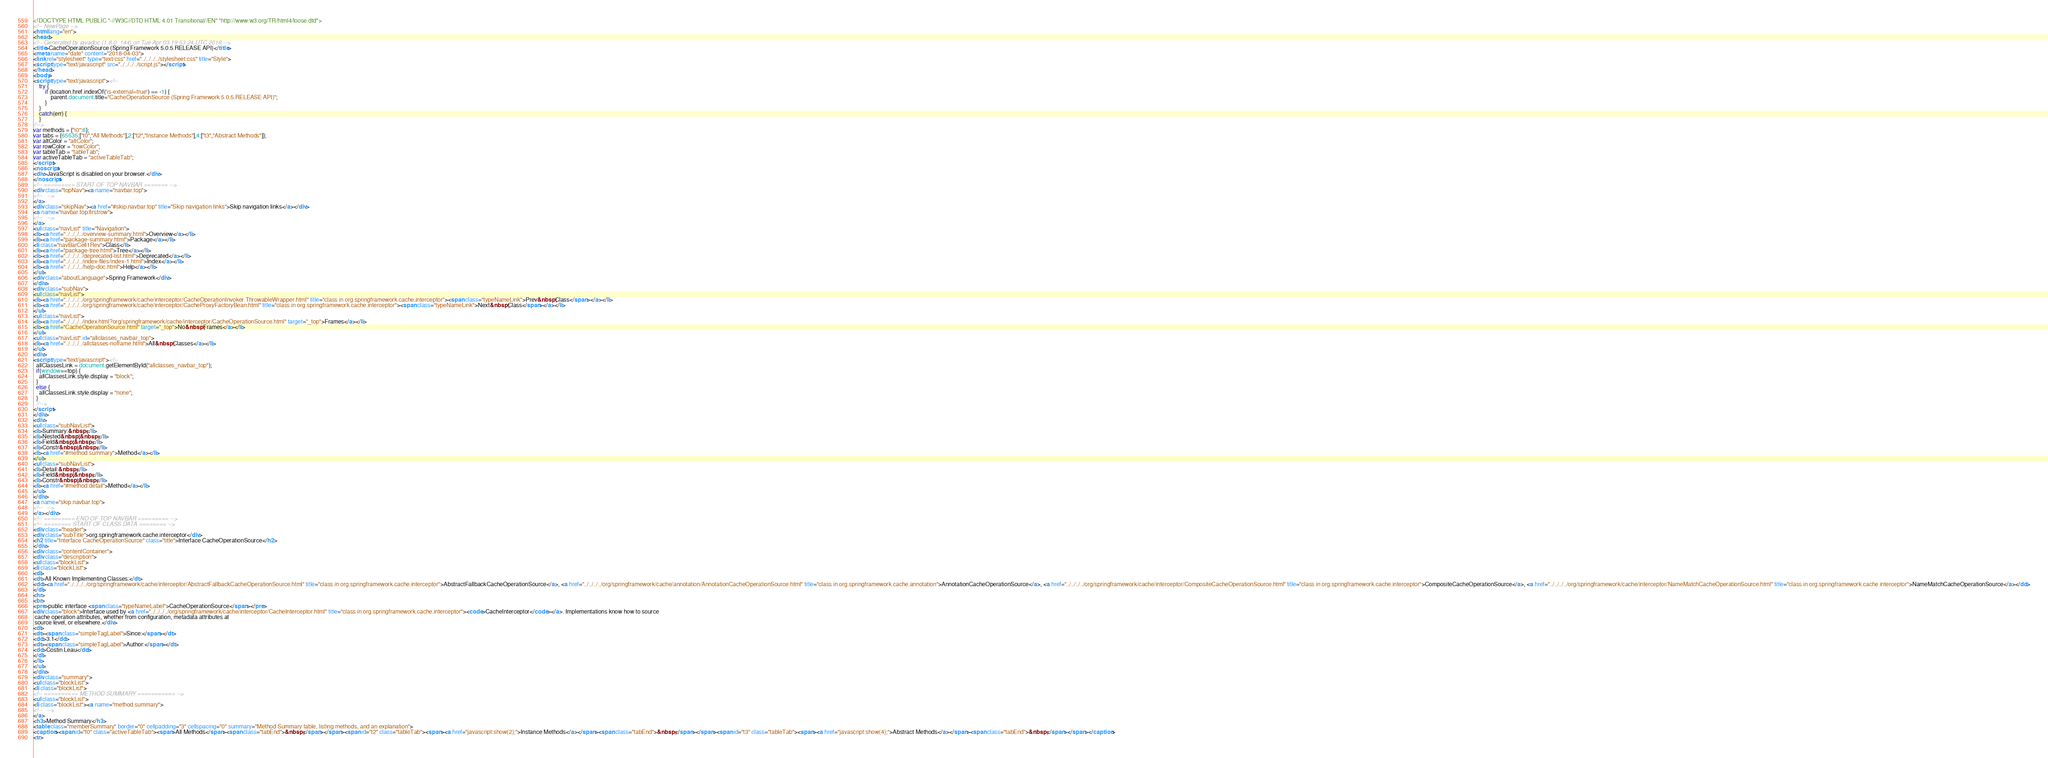<code> <loc_0><loc_0><loc_500><loc_500><_HTML_><!DOCTYPE HTML PUBLIC "-//W3C//DTD HTML 4.01 Transitional//EN" "http://www.w3.org/TR/html4/loose.dtd">
<!-- NewPage -->
<html lang="en">
<head>
<!-- Generated by javadoc (1.8.0_144) on Tue Apr 03 19:53:24 UTC 2018 -->
<title>CacheOperationSource (Spring Framework 5.0.5.RELEASE API)</title>
<meta name="date" content="2018-04-03">
<link rel="stylesheet" type="text/css" href="../../../../stylesheet.css" title="Style">
<script type="text/javascript" src="../../../../script.js"></script>
</head>
<body>
<script type="text/javascript"><!--
    try {
        if (location.href.indexOf('is-external=true') == -1) {
            parent.document.title="CacheOperationSource (Spring Framework 5.0.5.RELEASE API)";
        }
    }
    catch(err) {
    }
//-->
var methods = {"i0":6};
var tabs = {65535:["t0","All Methods"],2:["t2","Instance Methods"],4:["t3","Abstract Methods"]};
var altColor = "altColor";
var rowColor = "rowColor";
var tableTab = "tableTab";
var activeTableTab = "activeTableTab";
</script>
<noscript>
<div>JavaScript is disabled on your browser.</div>
</noscript>
<!-- ========= START OF TOP NAVBAR ======= -->
<div class="topNav"><a name="navbar.top">
<!--   -->
</a>
<div class="skipNav"><a href="#skip.navbar.top" title="Skip navigation links">Skip navigation links</a></div>
<a name="navbar.top.firstrow">
<!--   -->
</a>
<ul class="navList" title="Navigation">
<li><a href="../../../../overview-summary.html">Overview</a></li>
<li><a href="package-summary.html">Package</a></li>
<li class="navBarCell1Rev">Class</li>
<li><a href="package-tree.html">Tree</a></li>
<li><a href="../../../../deprecated-list.html">Deprecated</a></li>
<li><a href="../../../../index-files/index-1.html">Index</a></li>
<li><a href="../../../../help-doc.html">Help</a></li>
</ul>
<div class="aboutLanguage">Spring Framework</div>
</div>
<div class="subNav">
<ul class="navList">
<li><a href="../../../../org/springframework/cache/interceptor/CacheOperationInvoker.ThrowableWrapper.html" title="class in org.springframework.cache.interceptor"><span class="typeNameLink">Prev&nbsp;Class</span></a></li>
<li><a href="../../../../org/springframework/cache/interceptor/CacheProxyFactoryBean.html" title="class in org.springframework.cache.interceptor"><span class="typeNameLink">Next&nbsp;Class</span></a></li>
</ul>
<ul class="navList">
<li><a href="../../../../index.html?org/springframework/cache/interceptor/CacheOperationSource.html" target="_top">Frames</a></li>
<li><a href="CacheOperationSource.html" target="_top">No&nbsp;Frames</a></li>
</ul>
<ul class="navList" id="allclasses_navbar_top">
<li><a href="../../../../allclasses-noframe.html">All&nbsp;Classes</a></li>
</ul>
<div>
<script type="text/javascript"><!--
  allClassesLink = document.getElementById("allclasses_navbar_top");
  if(window==top) {
    allClassesLink.style.display = "block";
  }
  else {
    allClassesLink.style.display = "none";
  }
  //-->
</script>
</div>
<div>
<ul class="subNavList">
<li>Summary:&nbsp;</li>
<li>Nested&nbsp;|&nbsp;</li>
<li>Field&nbsp;|&nbsp;</li>
<li>Constr&nbsp;|&nbsp;</li>
<li><a href="#method.summary">Method</a></li>
</ul>
<ul class="subNavList">
<li>Detail:&nbsp;</li>
<li>Field&nbsp;|&nbsp;</li>
<li>Constr&nbsp;|&nbsp;</li>
<li><a href="#method.detail">Method</a></li>
</ul>
</div>
<a name="skip.navbar.top">
<!--   -->
</a></div>
<!-- ========= END OF TOP NAVBAR ========= -->
<!-- ======== START OF CLASS DATA ======== -->
<div class="header">
<div class="subTitle">org.springframework.cache.interceptor</div>
<h2 title="Interface CacheOperationSource" class="title">Interface CacheOperationSource</h2>
</div>
<div class="contentContainer">
<div class="description">
<ul class="blockList">
<li class="blockList">
<dl>
<dt>All Known Implementing Classes:</dt>
<dd><a href="../../../../org/springframework/cache/interceptor/AbstractFallbackCacheOperationSource.html" title="class in org.springframework.cache.interceptor">AbstractFallbackCacheOperationSource</a>, <a href="../../../../org/springframework/cache/annotation/AnnotationCacheOperationSource.html" title="class in org.springframework.cache.annotation">AnnotationCacheOperationSource</a>, <a href="../../../../org/springframework/cache/interceptor/CompositeCacheOperationSource.html" title="class in org.springframework.cache.interceptor">CompositeCacheOperationSource</a>, <a href="../../../../org/springframework/cache/interceptor/NameMatchCacheOperationSource.html" title="class in org.springframework.cache.interceptor">NameMatchCacheOperationSource</a></dd>
</dl>
<hr>
<br>
<pre>public interface <span class="typeNameLabel">CacheOperationSource</span></pre>
<div class="block">Interface used by <a href="../../../../org/springframework/cache/interceptor/CacheInterceptor.html" title="class in org.springframework.cache.interceptor"><code>CacheInterceptor</code></a>. Implementations know how to source
 cache operation attributes, whether from configuration, metadata attributes at
 source level, or elsewhere.</div>
<dl>
<dt><span class="simpleTagLabel">Since:</span></dt>
<dd>3.1</dd>
<dt><span class="simpleTagLabel">Author:</span></dt>
<dd>Costin Leau</dd>
</dl>
</li>
</ul>
</div>
<div class="summary">
<ul class="blockList">
<li class="blockList">
<!-- ========== METHOD SUMMARY =========== -->
<ul class="blockList">
<li class="blockList"><a name="method.summary">
<!--   -->
</a>
<h3>Method Summary</h3>
<table class="memberSummary" border="0" cellpadding="3" cellspacing="0" summary="Method Summary table, listing methods, and an explanation">
<caption><span id="t0" class="activeTableTab"><span>All Methods</span><span class="tabEnd">&nbsp;</span></span><span id="t2" class="tableTab"><span><a href="javascript:show(2);">Instance Methods</a></span><span class="tabEnd">&nbsp;</span></span><span id="t3" class="tableTab"><span><a href="javascript:show(4);">Abstract Methods</a></span><span class="tabEnd">&nbsp;</span></span></caption>
<tr></code> 